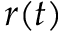Convert formula to latex. <formula><loc_0><loc_0><loc_500><loc_500>r ( t )</formula> 